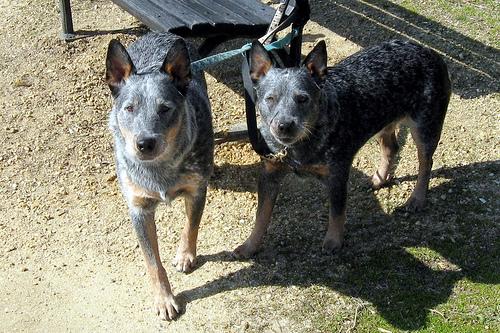How many dogs are in the photo?
Quick response, please. 2. What are theses dogs tied to?
Short answer required. Bench. Are these wolves?
Give a very brief answer. No. 